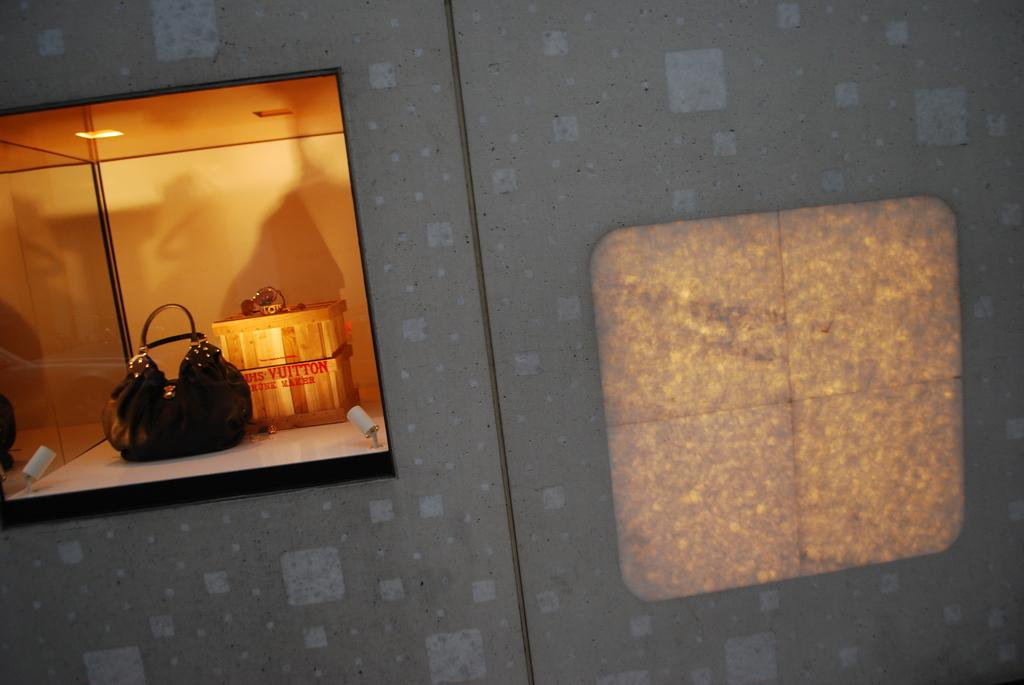What object can be seen in the image that is typically used for carrying items? There is a bag in the image that is typically used for carrying items. What other object can be seen in the image that is made of wood? There is a wooden-box in the image that is made of wood. Where are the bag and wooden-box located in the image? The bag and wooden-box are inside a window in the image. What type of design can be seen on the bag in the image? There is no information provided about the design on the bag in the image. --- 